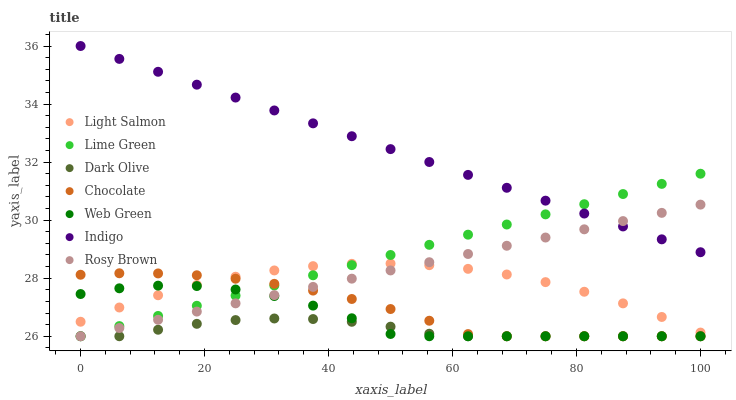Does Dark Olive have the minimum area under the curve?
Answer yes or no. Yes. Does Indigo have the maximum area under the curve?
Answer yes or no. Yes. Does Rosy Brown have the minimum area under the curve?
Answer yes or no. No. Does Rosy Brown have the maximum area under the curve?
Answer yes or no. No. Is Indigo the smoothest?
Answer yes or no. Yes. Is Web Green the roughest?
Answer yes or no. Yes. Is Rosy Brown the smoothest?
Answer yes or no. No. Is Rosy Brown the roughest?
Answer yes or no. No. Does Rosy Brown have the lowest value?
Answer yes or no. Yes. Does Indigo have the lowest value?
Answer yes or no. No. Does Indigo have the highest value?
Answer yes or no. Yes. Does Rosy Brown have the highest value?
Answer yes or no. No. Is Dark Olive less than Indigo?
Answer yes or no. Yes. Is Light Salmon greater than Dark Olive?
Answer yes or no. Yes. Does Lime Green intersect Dark Olive?
Answer yes or no. Yes. Is Lime Green less than Dark Olive?
Answer yes or no. No. Is Lime Green greater than Dark Olive?
Answer yes or no. No. Does Dark Olive intersect Indigo?
Answer yes or no. No. 